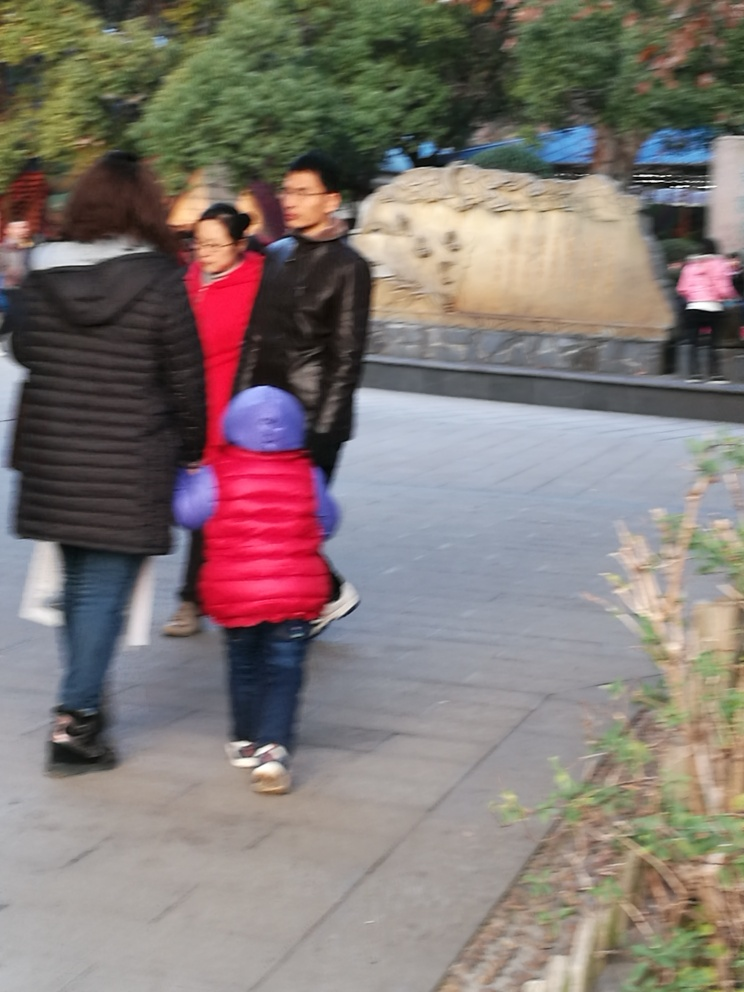What makes it hard to distinguish the subject in this image?
A. clear outlines
B. blurry outlines
C. high resolution
Answer with the option's letter from the given choices directly.
 B. 